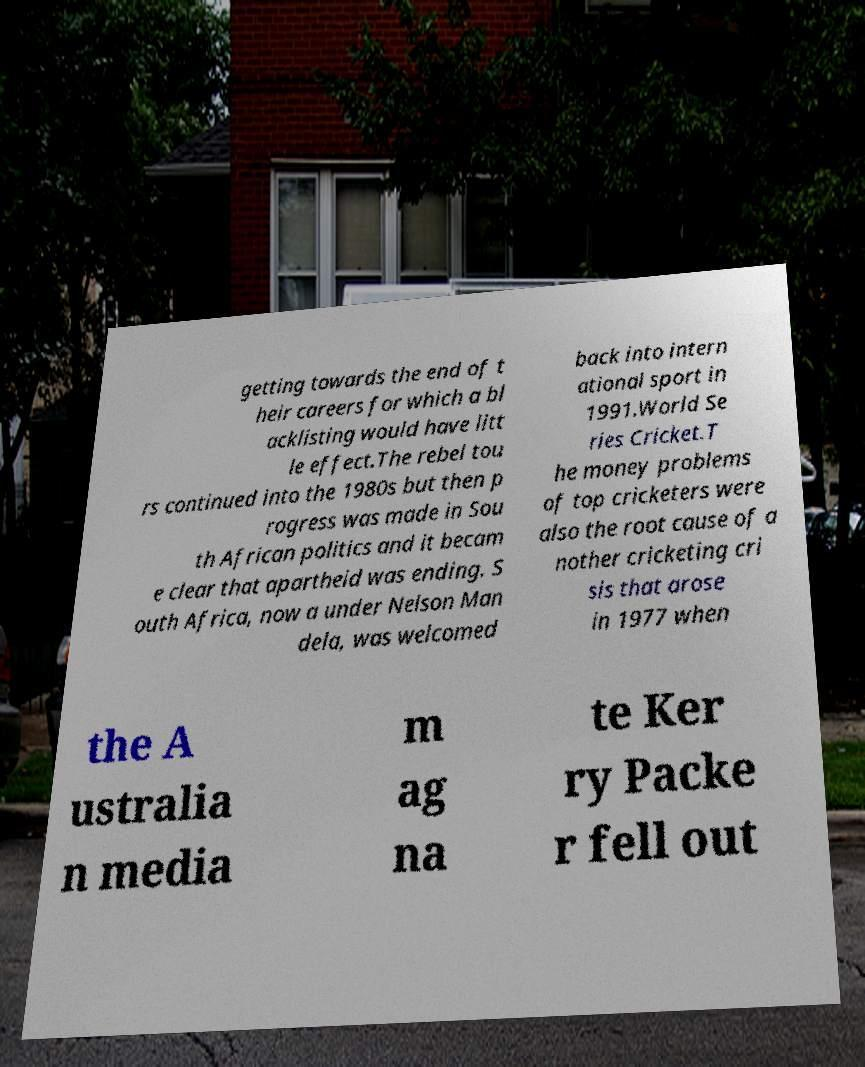What messages or text are displayed in this image? I need them in a readable, typed format. getting towards the end of t heir careers for which a bl acklisting would have litt le effect.The rebel tou rs continued into the 1980s but then p rogress was made in Sou th African politics and it becam e clear that apartheid was ending. S outh Africa, now a under Nelson Man dela, was welcomed back into intern ational sport in 1991.World Se ries Cricket.T he money problems of top cricketers were also the root cause of a nother cricketing cri sis that arose in 1977 when the A ustralia n media m ag na te Ker ry Packe r fell out 